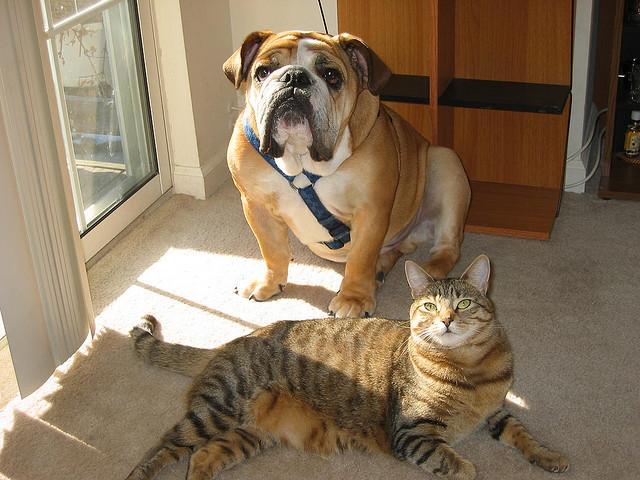How many pets do you see?
Answer briefly. 2. What are the two kinds of animals that you see in the picture?
Be succinct. Cat and dog. Are the animals inside or outside?
Give a very brief answer. Inside. 